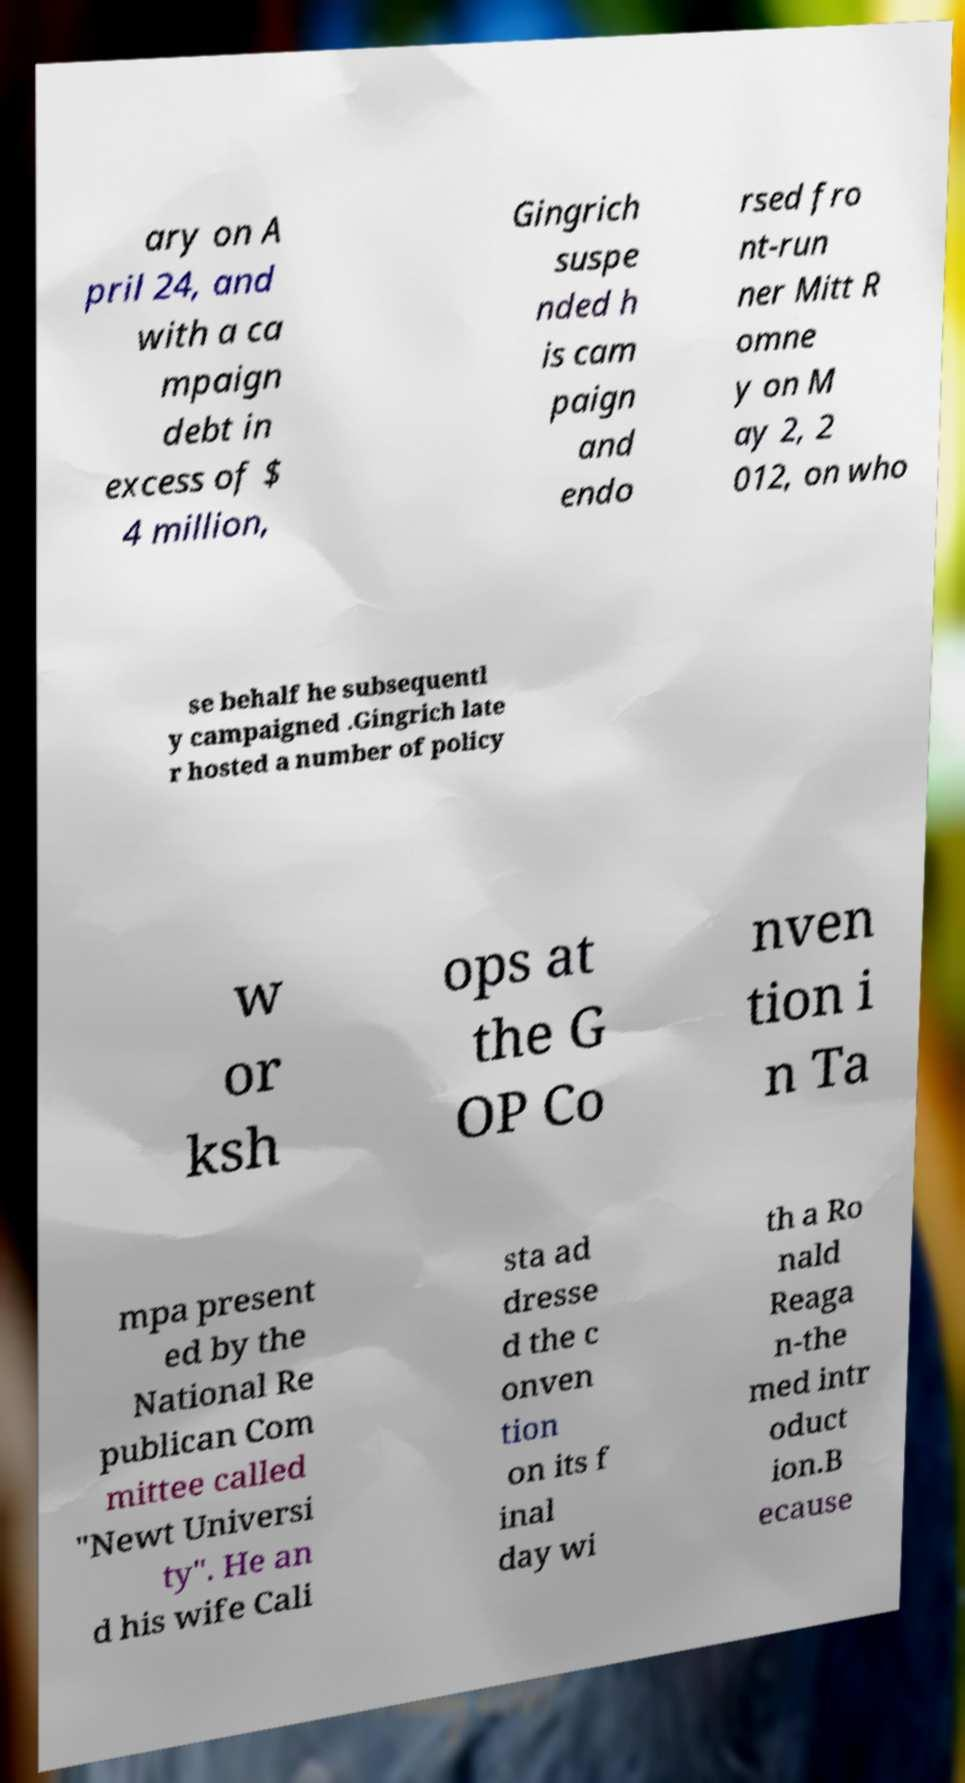Could you assist in decoding the text presented in this image and type it out clearly? ary on A pril 24, and with a ca mpaign debt in excess of $ 4 million, Gingrich suspe nded h is cam paign and endo rsed fro nt-run ner Mitt R omne y on M ay 2, 2 012, on who se behalf he subsequentl y campaigned .Gingrich late r hosted a number of policy w or ksh ops at the G OP Co nven tion i n Ta mpa present ed by the National Re publican Com mittee called "Newt Universi ty". He an d his wife Cali sta ad dresse d the c onven tion on its f inal day wi th a Ro nald Reaga n-the med intr oduct ion.B ecause 